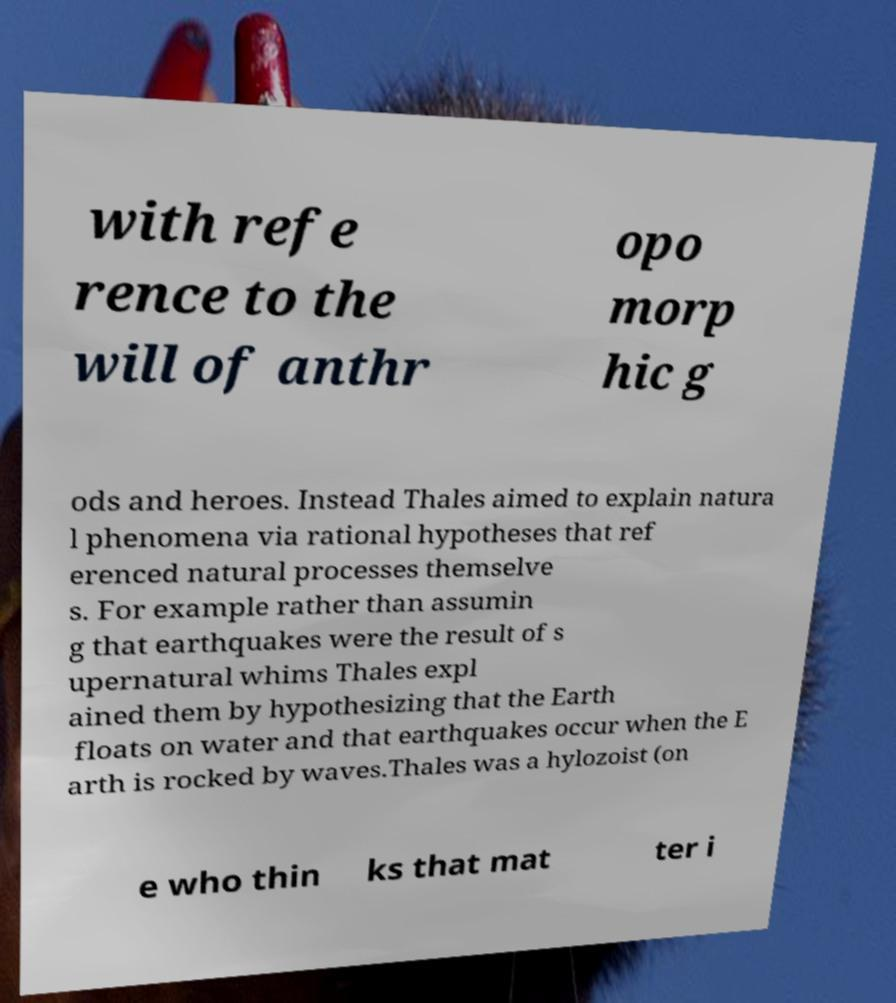I need the written content from this picture converted into text. Can you do that? with refe rence to the will of anthr opo morp hic g ods and heroes. Instead Thales aimed to explain natura l phenomena via rational hypotheses that ref erenced natural processes themselve s. For example rather than assumin g that earthquakes were the result of s upernatural whims Thales expl ained them by hypothesizing that the Earth floats on water and that earthquakes occur when the E arth is rocked by waves.Thales was a hylozoist (on e who thin ks that mat ter i 